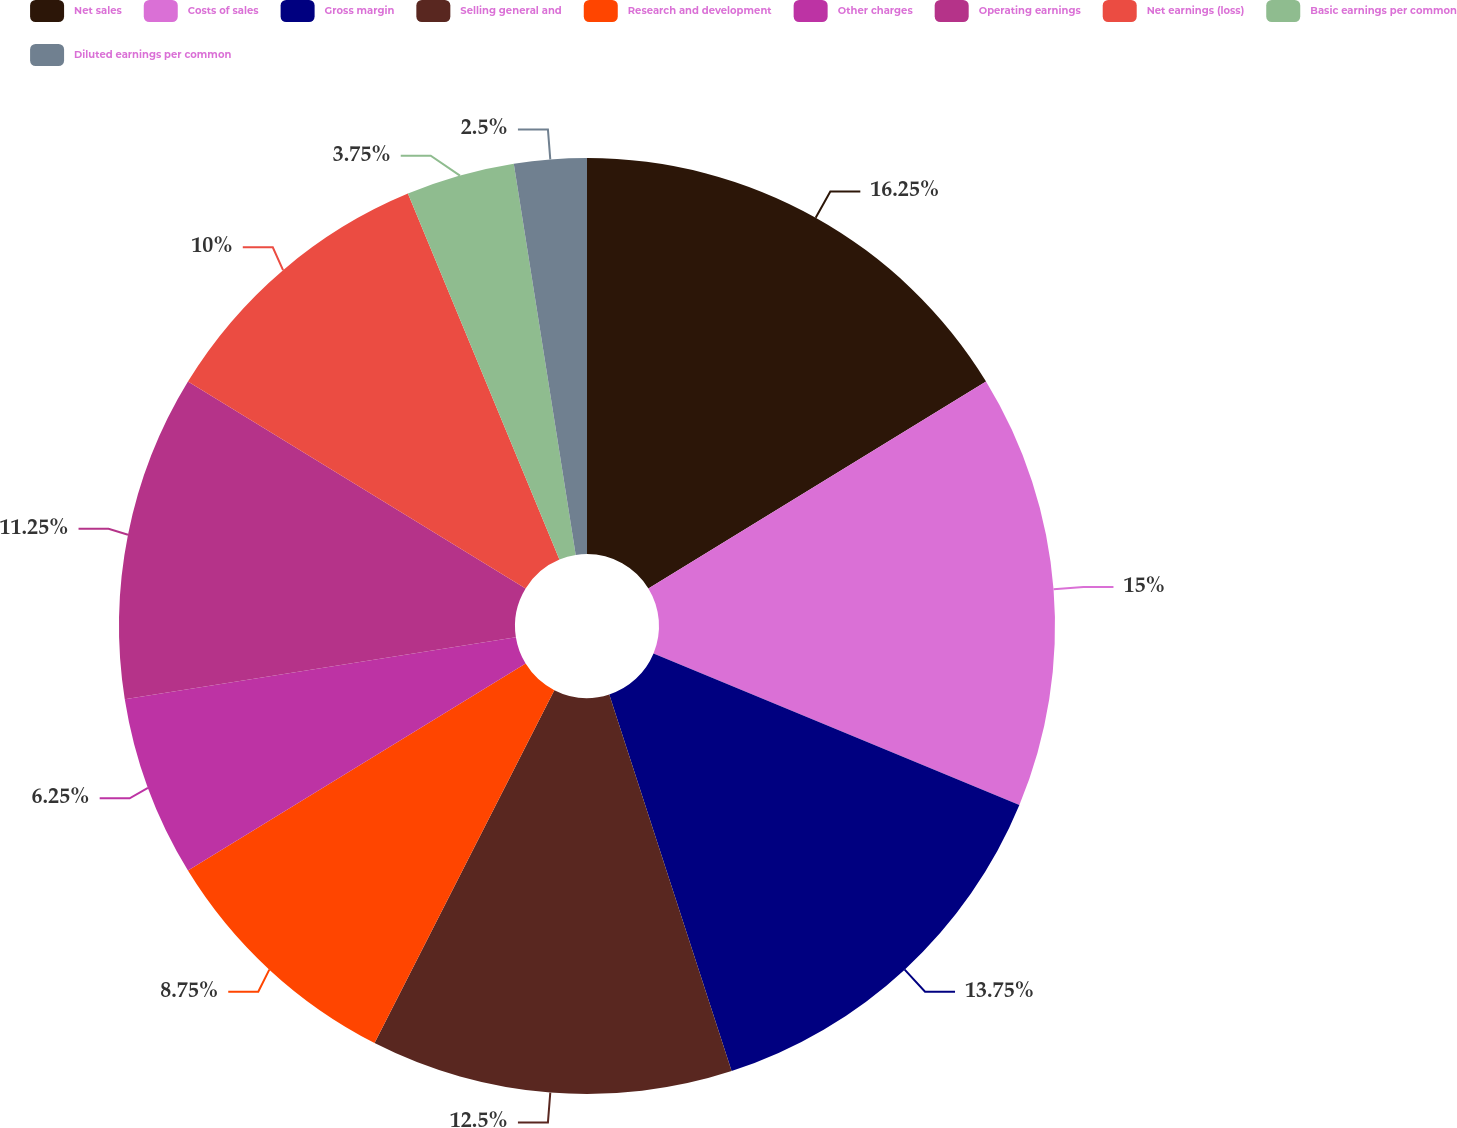Convert chart to OTSL. <chart><loc_0><loc_0><loc_500><loc_500><pie_chart><fcel>Net sales<fcel>Costs of sales<fcel>Gross margin<fcel>Selling general and<fcel>Research and development<fcel>Other charges<fcel>Operating earnings<fcel>Net earnings (loss)<fcel>Basic earnings per common<fcel>Diluted earnings per common<nl><fcel>16.25%<fcel>15.0%<fcel>13.75%<fcel>12.5%<fcel>8.75%<fcel>6.25%<fcel>11.25%<fcel>10.0%<fcel>3.75%<fcel>2.5%<nl></chart> 